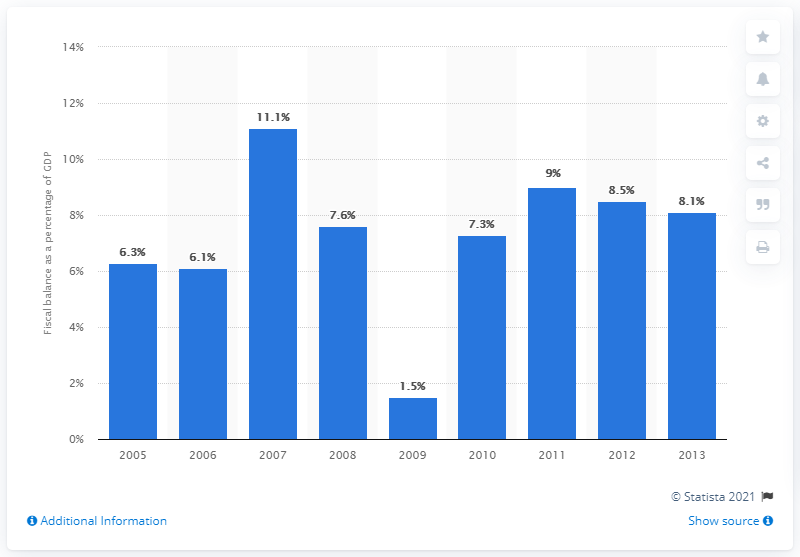Draw attention to some important aspects in this diagram. In 2010, the fiscal balance of Singapore was 7.3. 